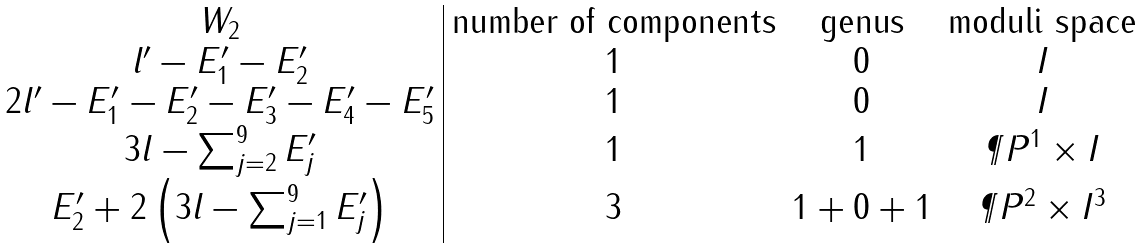<formula> <loc_0><loc_0><loc_500><loc_500>\begin{array} { c | c c c } W _ { 2 } & \text {number of components} & \text {genus} & \text {moduli space} \\ l ^ { \prime } - E ^ { \prime } _ { 1 } - E ^ { \prime } _ { 2 } & 1 & 0 & I \\ 2 l ^ { \prime } - E ^ { \prime } _ { 1 } - E ^ { \prime } _ { 2 } - E ^ { \prime } _ { 3 } - E ^ { \prime } _ { 4 } - E ^ { \prime } _ { 5 } & 1 & 0 & I \\ 3 l - \sum _ { j = 2 } ^ { 9 } E ^ { \prime } _ { j } & 1 & 1 & \P P ^ { 1 } \times I \\ E ^ { \prime } _ { 2 } + 2 \left ( 3 l - \sum _ { j = 1 } ^ { 9 } E ^ { \prime } _ { j } \right ) & 3 & 1 + 0 + 1 & \P P ^ { 2 } \times I ^ { 3 } \end{array}</formula> 